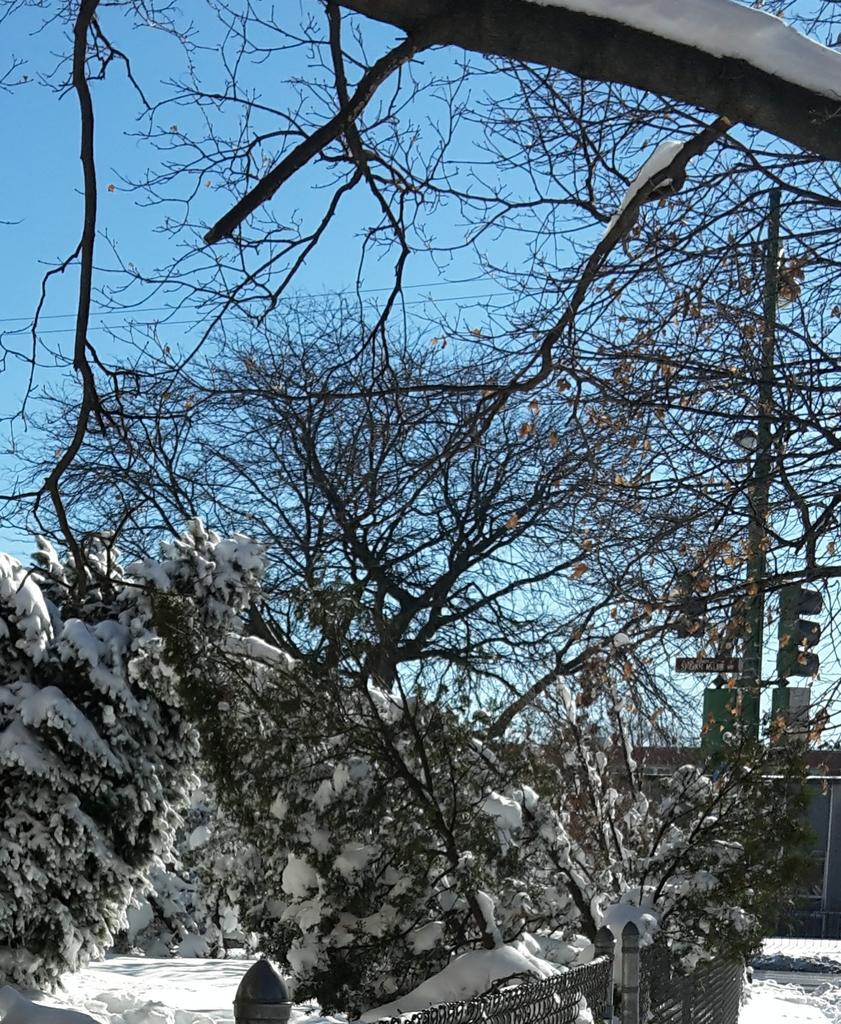Please provide a concise description of this image. In this picture I can see trees, pole which has wires attached to it and traffic light. Here I can see snow and the sky in the background. 